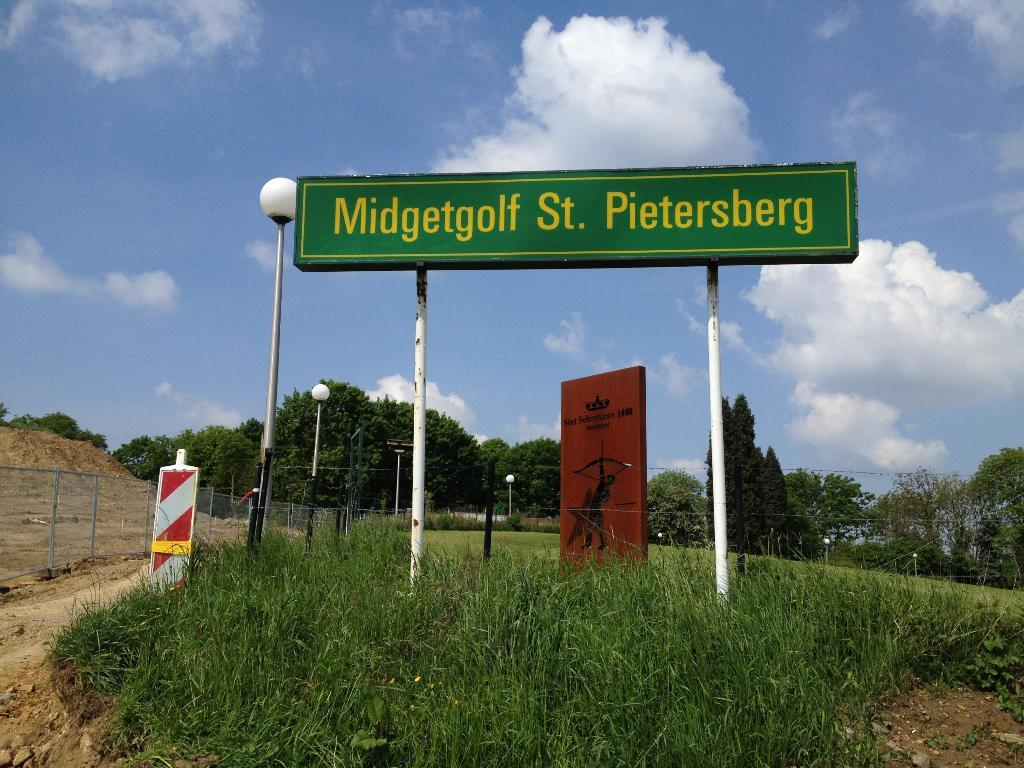<image>
Render a clear and concise summary of the photo. A road sign identifies a location as Midgetgolf St. Pietersberg. 